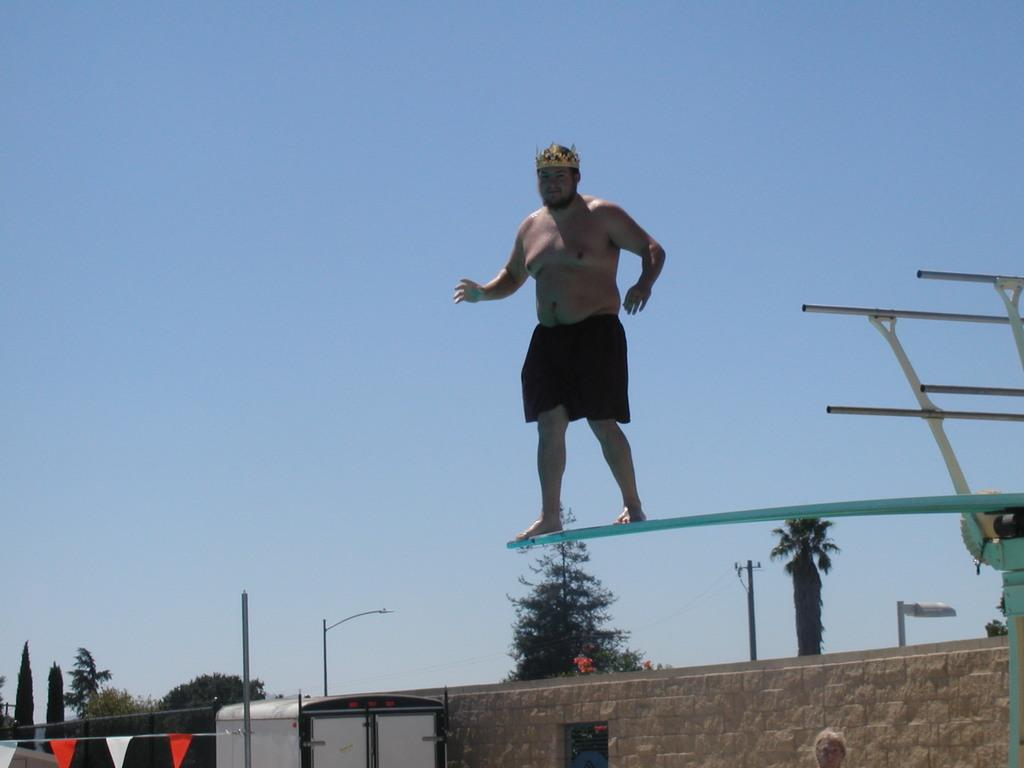What is the main subject of the image? There is a person standing on a board in the center of the image. What can be seen at the bottom of the image? There are houses, a wall, poles, flags, and trees at the bottom of the image. What is visible at the top of the image? The sky is visible at the top of the image. What type of oatmeal is being served in the image? There is no oatmeal present in the image. Can you describe the trail that the person is walking on in the image? There is no trail visible in the image; the person is standing on a board. 